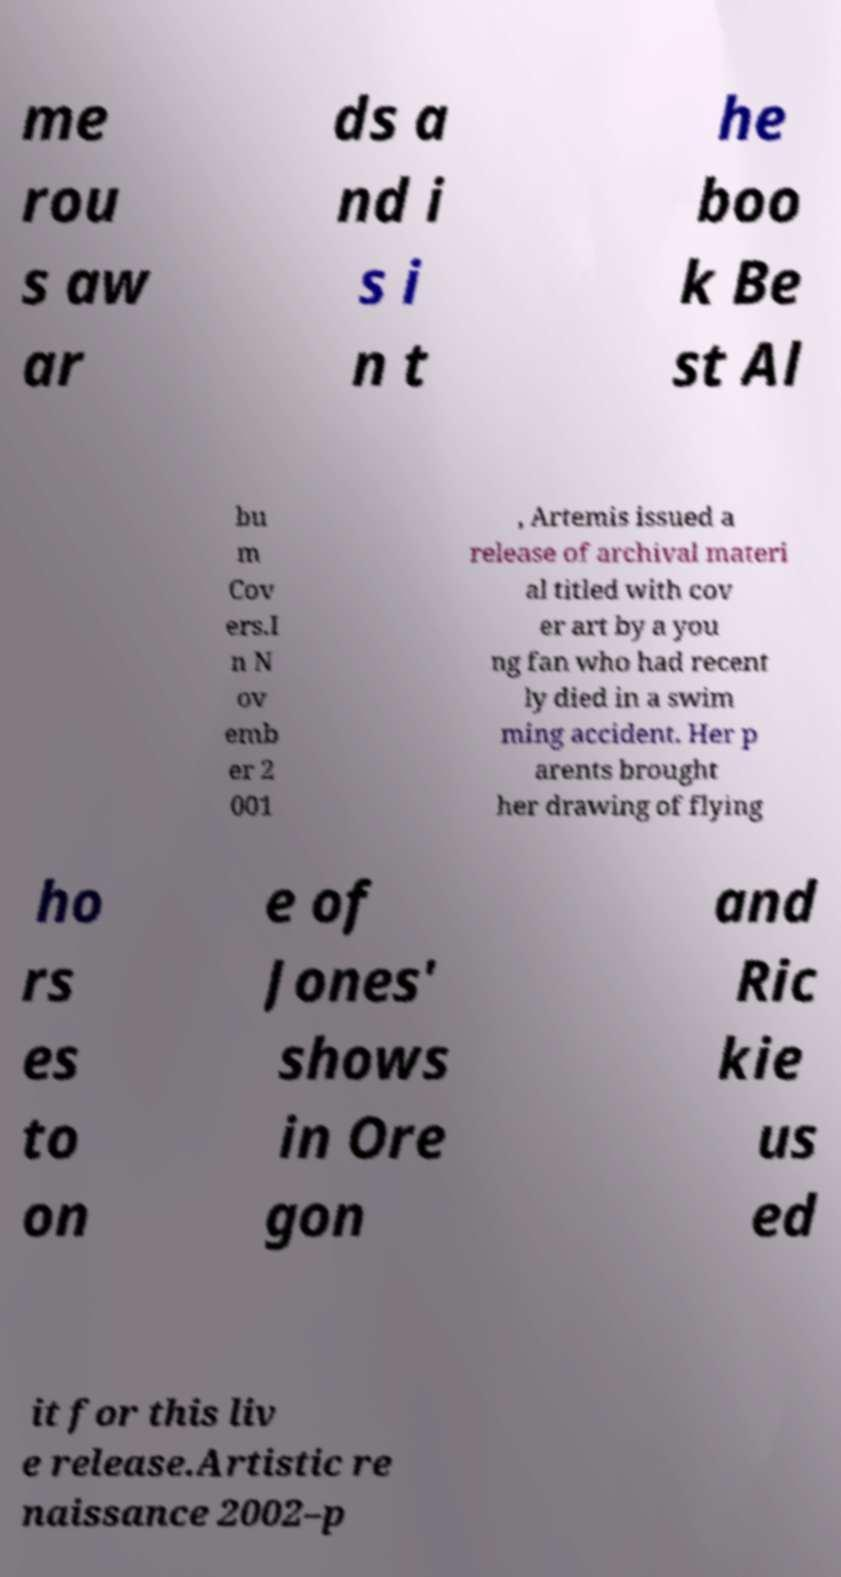Please read and relay the text visible in this image. What does it say? me rou s aw ar ds a nd i s i n t he boo k Be st Al bu m Cov ers.I n N ov emb er 2 001 , Artemis issued a release of archival materi al titled with cov er art by a you ng fan who had recent ly died in a swim ming accident. Her p arents brought her drawing of flying ho rs es to on e of Jones' shows in Ore gon and Ric kie us ed it for this liv e release.Artistic re naissance 2002–p 